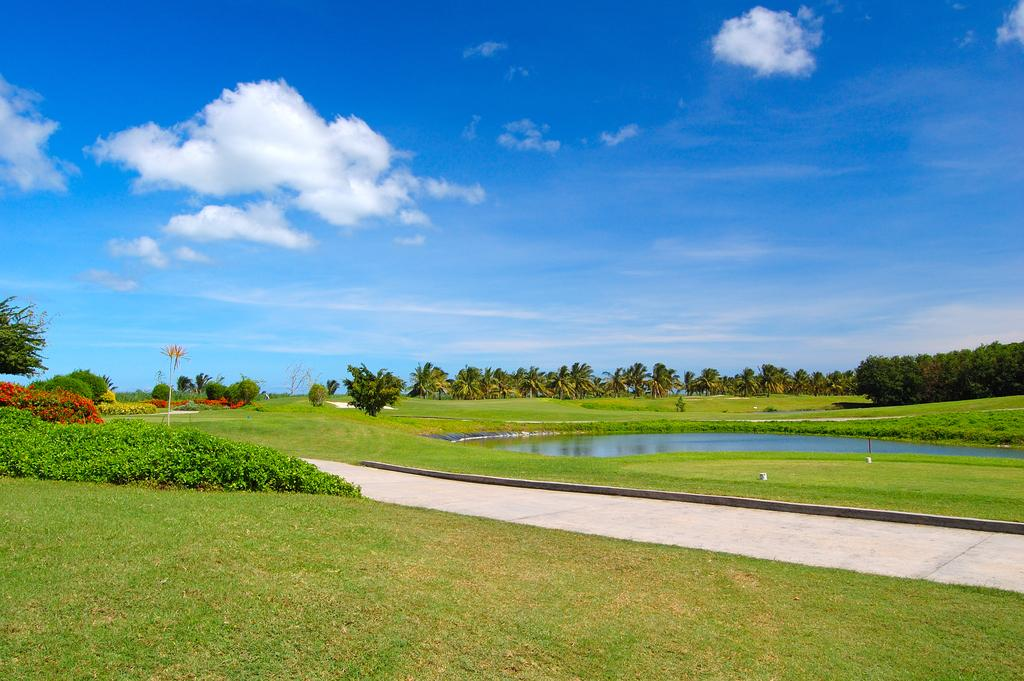What type of vegetation is present in the image? There is grass and trees in the image. What natural feature can be seen in the image? There is a pond of water in the image. How many chairs are placed around the pond in the image? There are no chairs present in the image. What is the boy doing near the pond in the image? There is no boy present in the image. 